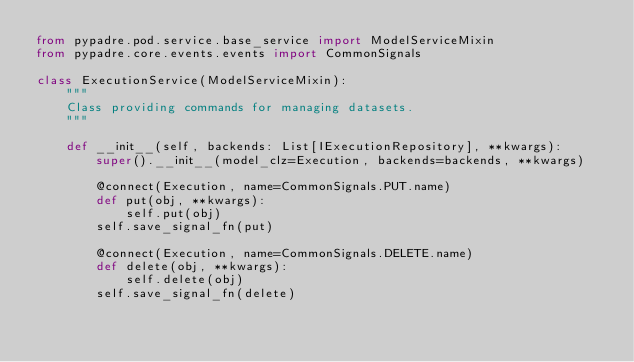Convert code to text. <code><loc_0><loc_0><loc_500><loc_500><_Python_>from pypadre.pod.service.base_service import ModelServiceMixin
from pypadre.core.events.events import CommonSignals

class ExecutionService(ModelServiceMixin):
    """
    Class providing commands for managing datasets.
    """

    def __init__(self, backends: List[IExecutionRepository], **kwargs):
        super().__init__(model_clz=Execution, backends=backends, **kwargs)

        @connect(Execution, name=CommonSignals.PUT.name)
        def put(obj, **kwargs):
            self.put(obj)
        self.save_signal_fn(put)

        @connect(Execution, name=CommonSignals.DELETE.name)
        def delete(obj, **kwargs):
            self.delete(obj)
        self.save_signal_fn(delete)
</code> 